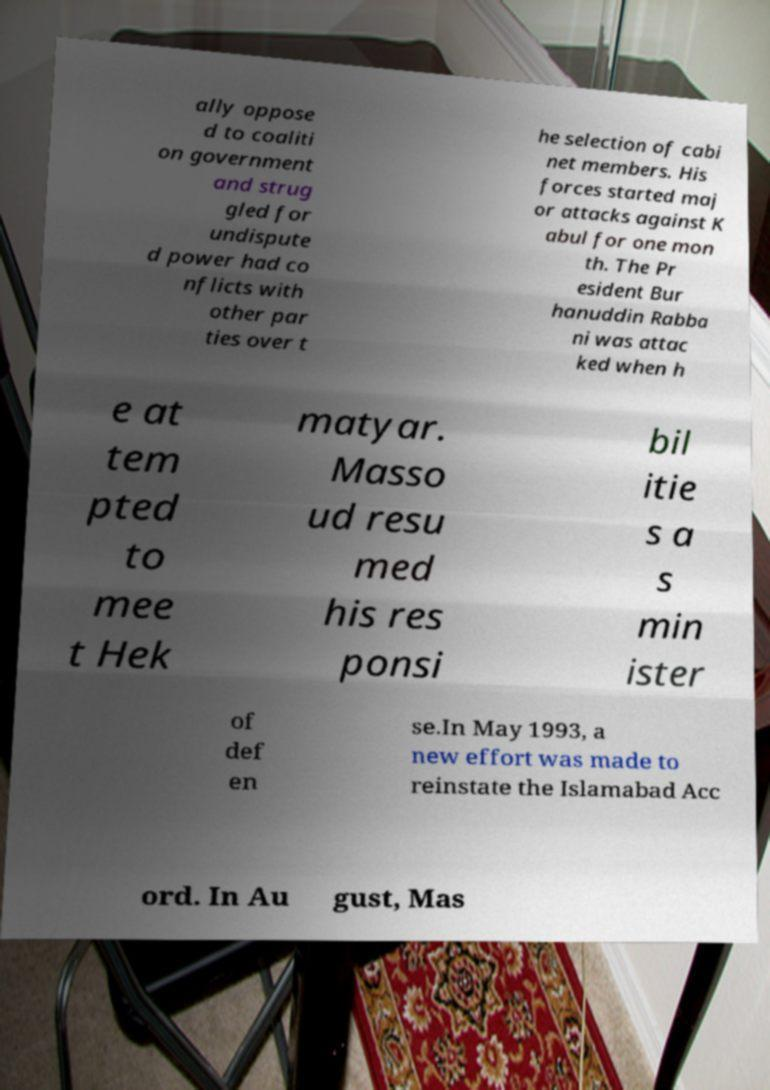Could you extract and type out the text from this image? ally oppose d to coaliti on government and strug gled for undispute d power had co nflicts with other par ties over t he selection of cabi net members. His forces started maj or attacks against K abul for one mon th. The Pr esident Bur hanuddin Rabba ni was attac ked when h e at tem pted to mee t Hek matyar. Masso ud resu med his res ponsi bil itie s a s min ister of def en se.In May 1993, a new effort was made to reinstate the Islamabad Acc ord. In Au gust, Mas 